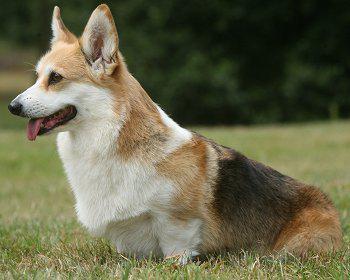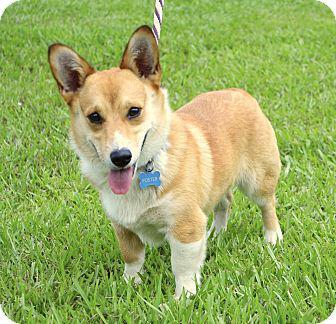The first image is the image on the left, the second image is the image on the right. Examine the images to the left and right. Is the description "The dog in the image on the right is standing on all fours in the grass." accurate? Answer yes or no. Yes. The first image is the image on the left, the second image is the image on the right. Considering the images on both sides, is "An image shows one dog with upright ears posed with white flowers." valid? Answer yes or no. No. 